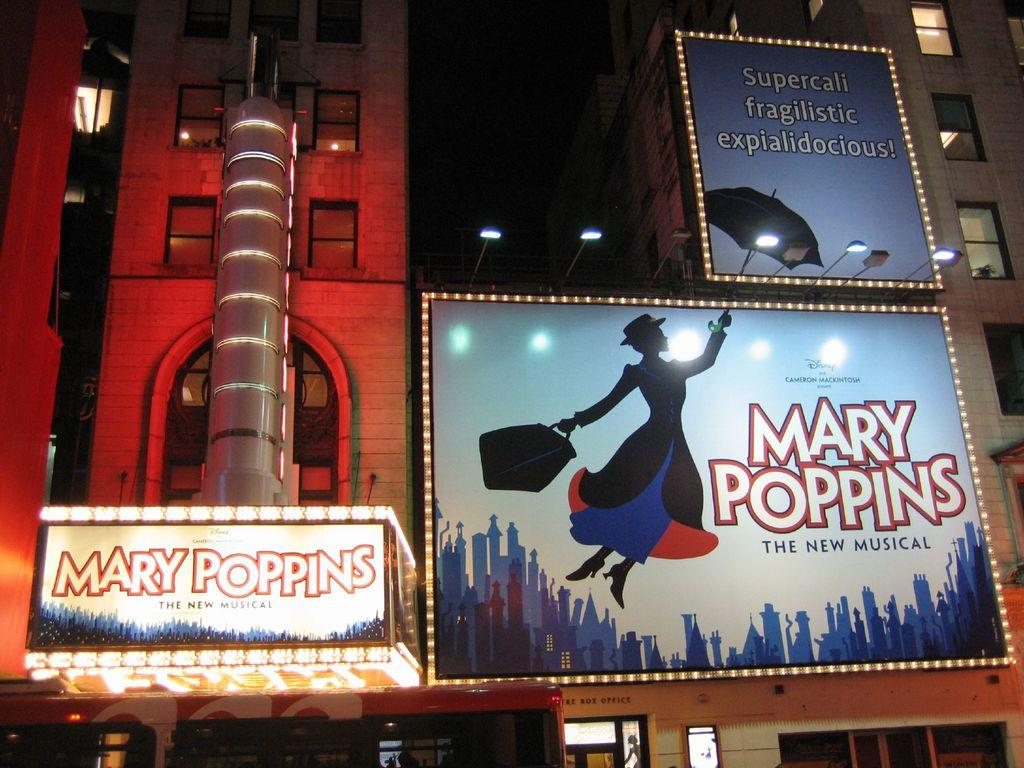<image>
Describe the image concisely. Marry Poppins musical billboard next to the entrance. 